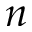<formula> <loc_0><loc_0><loc_500><loc_500>n</formula> 